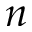<formula> <loc_0><loc_0><loc_500><loc_500>n</formula> 